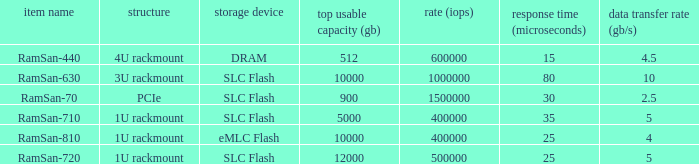What is the shape distortion for the range frequency of 10? 3U rackmount. 